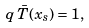Convert formula to latex. <formula><loc_0><loc_0><loc_500><loc_500>q \, \bar { T } ( { x } _ { s } ) = 1 ,</formula> 